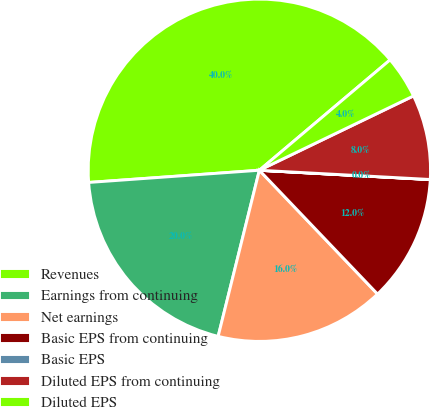<chart> <loc_0><loc_0><loc_500><loc_500><pie_chart><fcel>Revenues<fcel>Earnings from continuing<fcel>Net earnings<fcel>Basic EPS from continuing<fcel>Basic EPS<fcel>Diluted EPS from continuing<fcel>Diluted EPS<nl><fcel>39.97%<fcel>19.99%<fcel>16.0%<fcel>12.0%<fcel>0.01%<fcel>8.01%<fcel>4.01%<nl></chart> 